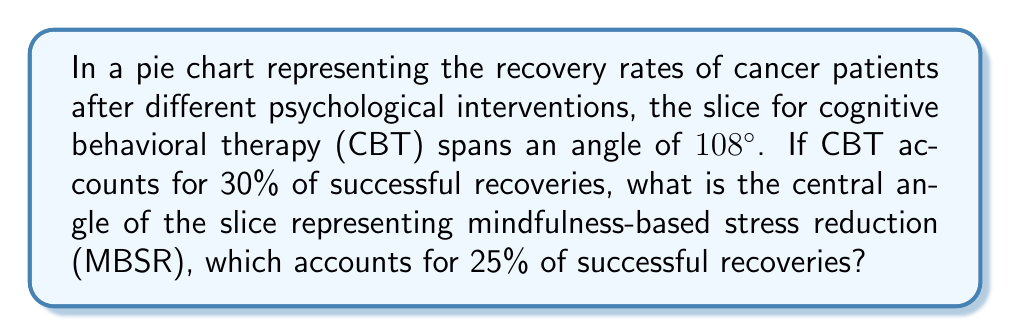Teach me how to tackle this problem. Let's approach this step-by-step:

1) In a pie chart, the total angle is 360°. Each slice's angle is proportional to the percentage it represents.

2) We're given that CBT spans 108° and accounts for 30% of recoveries. We can use this to find the angle for 1% of recoveries:

   $\frac{108°}{30\%} = 3.6°$ per 1%

3) Now, we know that MBSR accounts for 25% of recoveries. To find its angle, we multiply 25 by 3.6°:

   $25 \times 3.6° = 90°$

4) We can verify this result using the proportion method:

   $$\frac{108°}{30\%} = \frac{x}{25\%}$$

   Cross multiply:
   $$108 \times 25 = 30x$$
   $$2700 = 30x$$
   $$x = 90°$$

Thus, the central angle for the MBSR slice is 90°.
Answer: 90° 